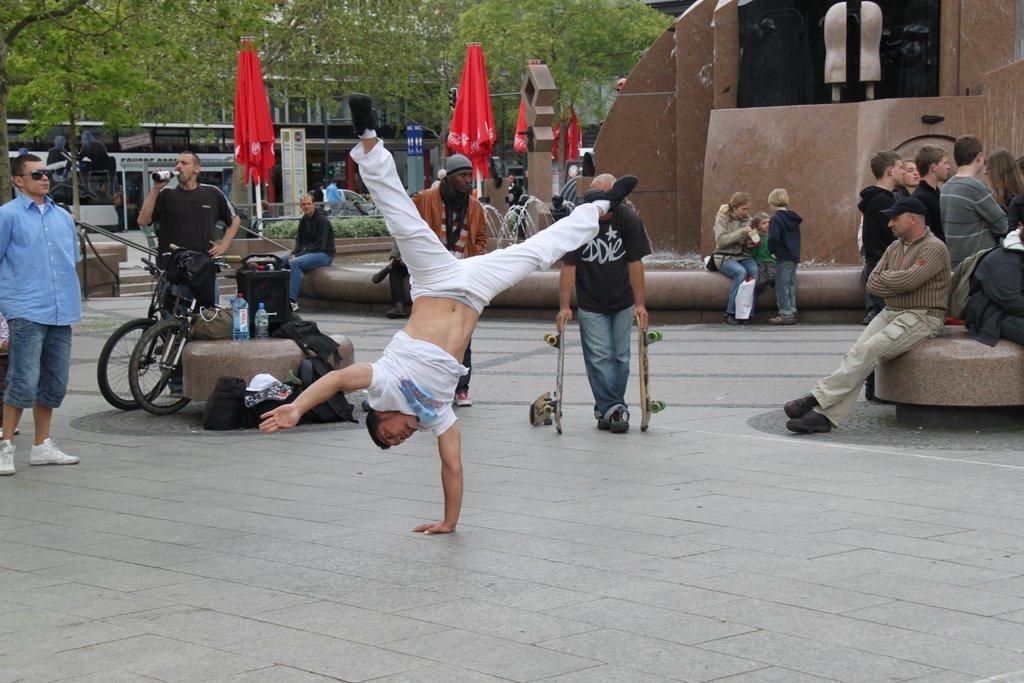Can you describe this image briefly? In this image there is a man doing gymnastic in the street , another man standing and watching him, another man standing near bicycle , there are group of people sitting beside him in the back ground there is water bottle, bag , flag , bus , building , tree. 